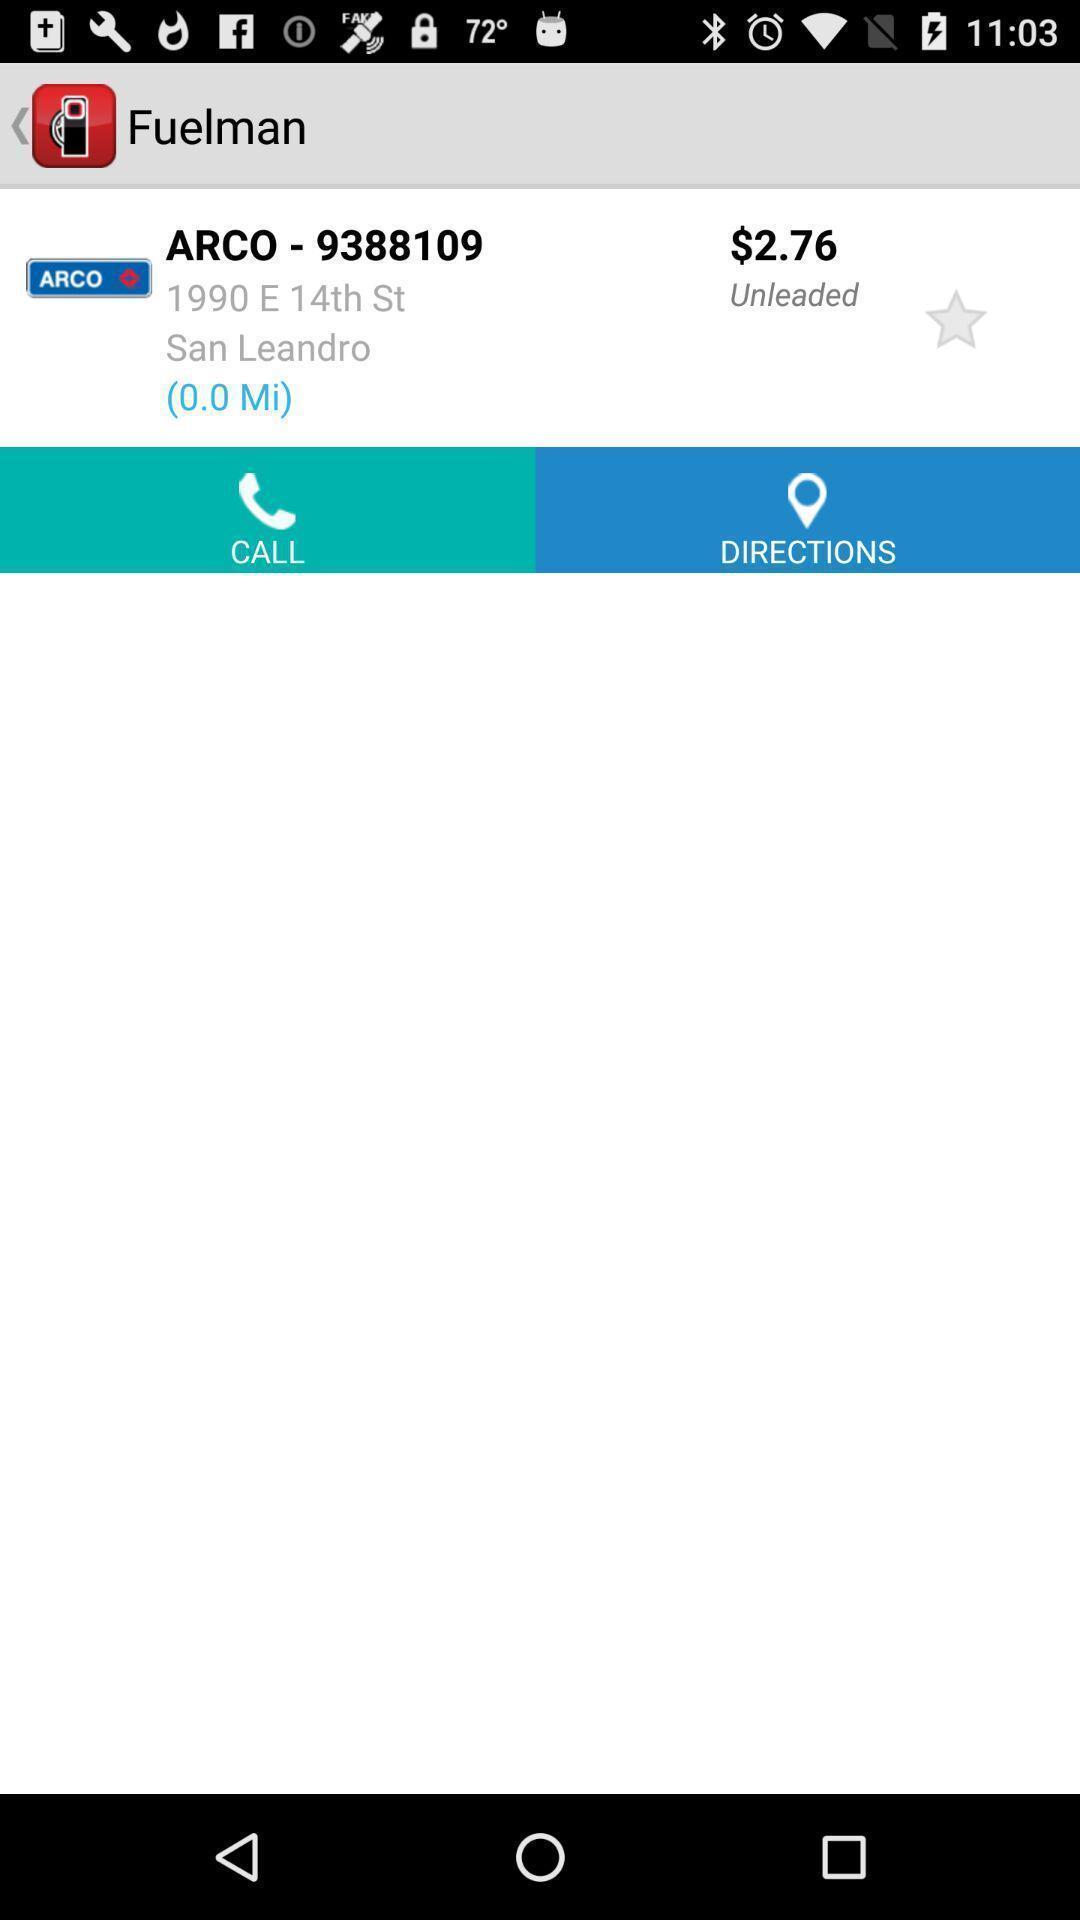Give me a summary of this screen capture. Page shows the fuelman station details and cost. 